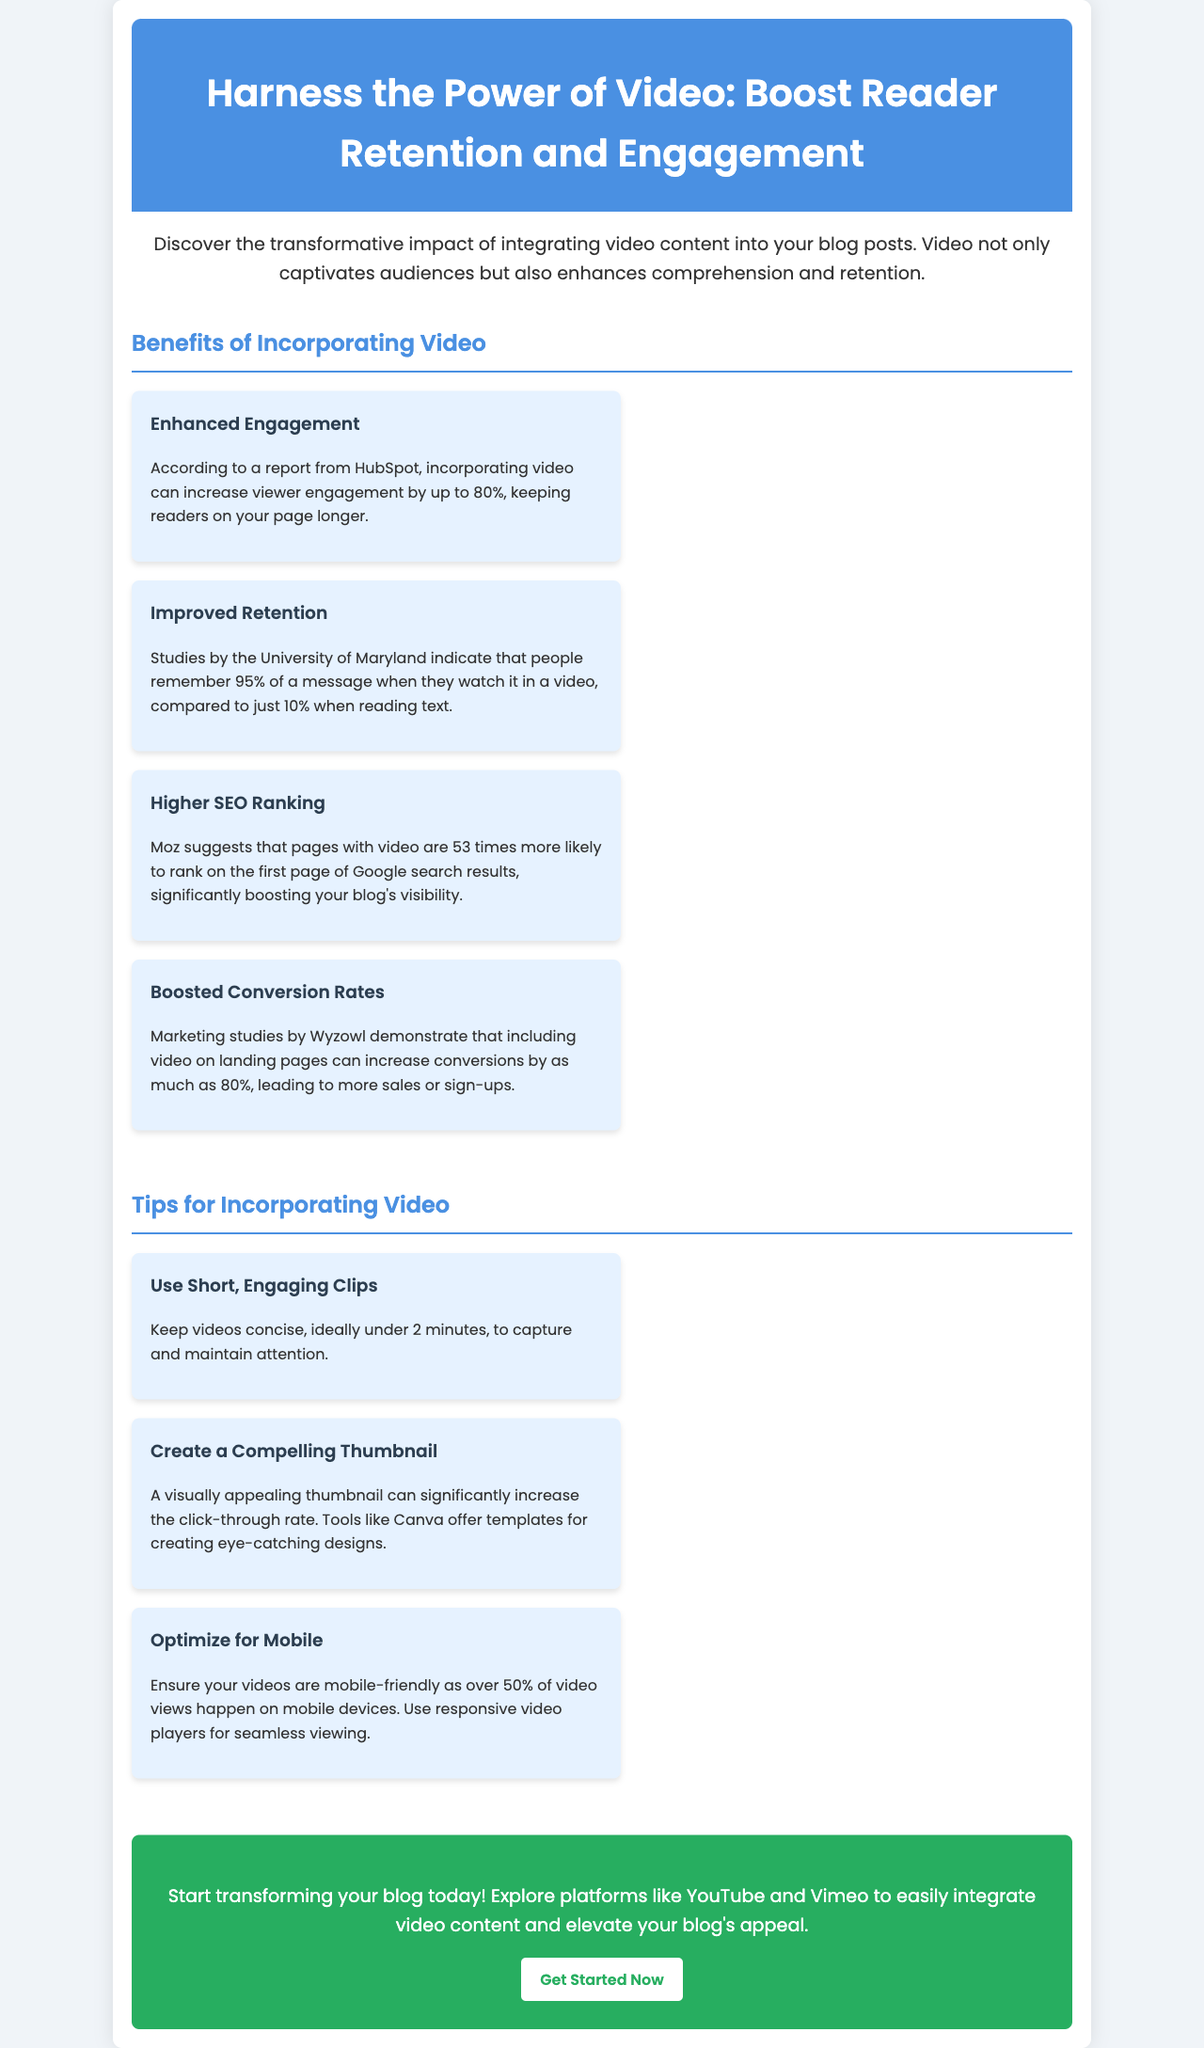What is the title of the brochure? The title of the brochure is presented prominently at the top of the document, reflecting its main theme.
Answer: Harness the Power of Video: Boost Reader Retention and Engagement How much can incorporating video increase viewer engagement? A specific percentage indicating the potential increase in engagement from adding video content is stated in the benefits section.
Answer: Up to 80% What do studies indicate about message retention when watched in a video? The document mentions a specific percentage regarding how much of a message people remember when it is presented in video format versus text.
Answer: 95% What is the suggested video length for maintaining attention? A recommendation is given in the tips section regarding the ideal duration of videos to keep viewers' attention.
Answer: Under 2 minutes Which platform is suggested for exploring video content integration? The document provides specific platforms where one can find video content options for enhancing blogs.
Answer: YouTube What is the estimated increase in conversions when including video on landing pages? The document cites a particular percentage that indicates likely improvement in conversion rates when video is included.
Answer: As much as 80% What is one way to increase click-through rates for videos? The tips section includes a specific method for improving the likelihood of viewers clicking on video content.
Answer: Create a Compelling Thumbnail What aspect of videos should be optimized for mobile? The document advises on a specific technical feature that should be ensured for video compatibility with mobile users.
Answer: Mobile-friendly 